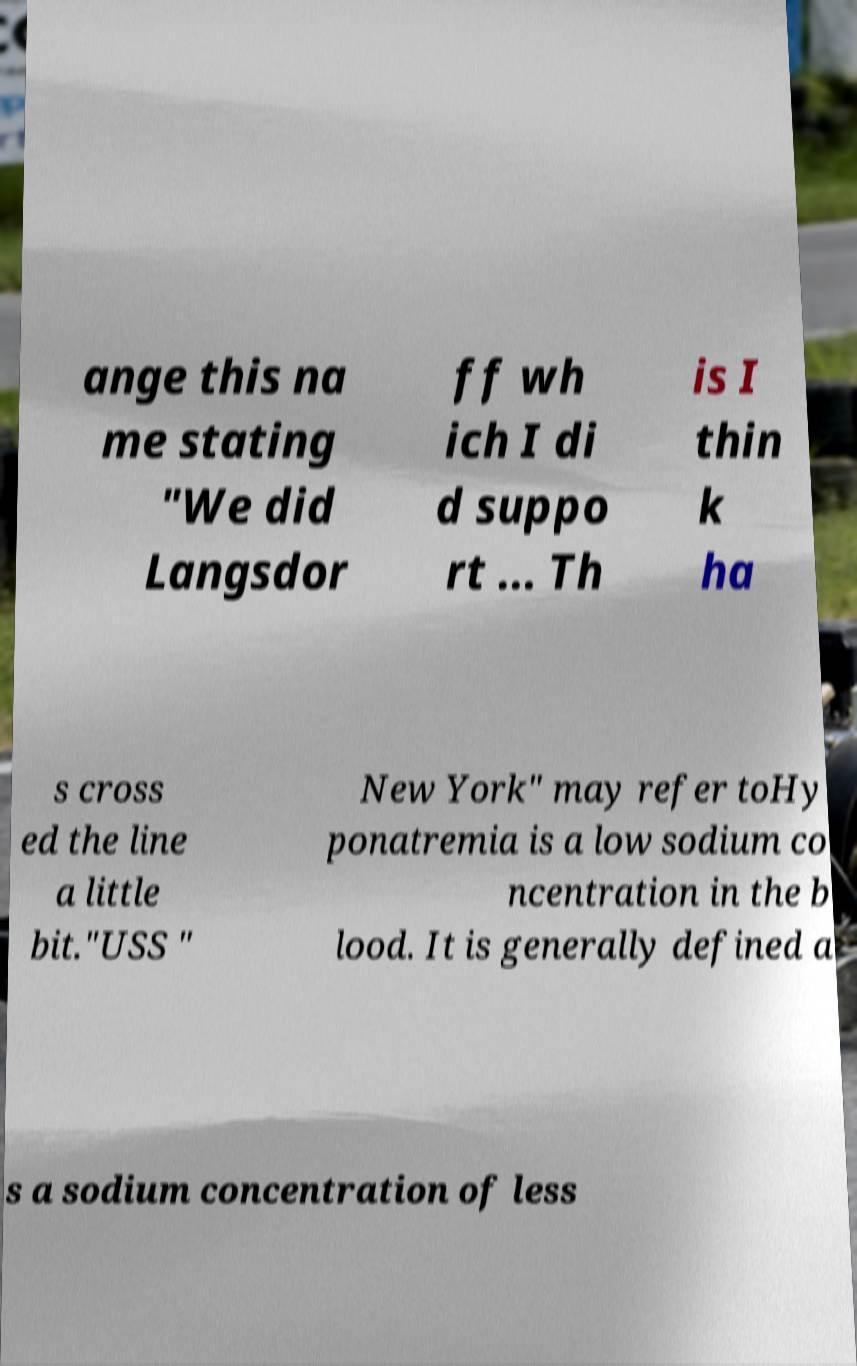Can you accurately transcribe the text from the provided image for me? ange this na me stating "We did Langsdor ff wh ich I di d suppo rt ... Th is I thin k ha s cross ed the line a little bit."USS " New York" may refer toHy ponatremia is a low sodium co ncentration in the b lood. It is generally defined a s a sodium concentration of less 